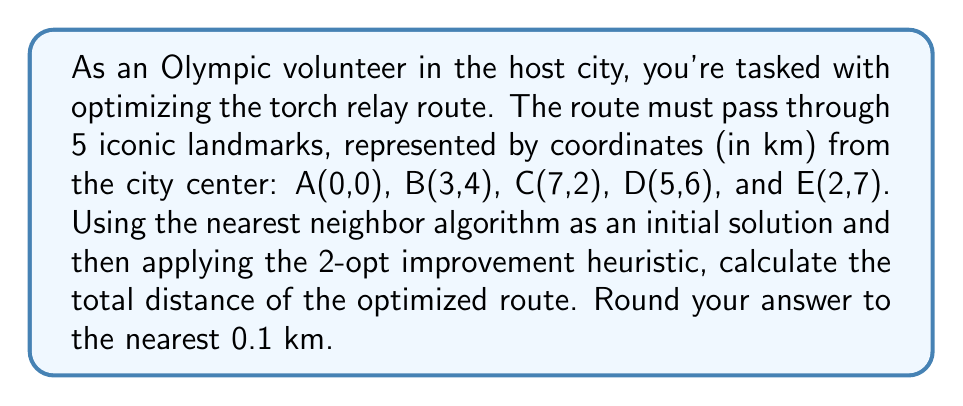Provide a solution to this math problem. 1) First, we'll use the nearest neighbor algorithm to find an initial route:
   Start at A(0,0)
   Closest to A: B(3,4), distance = $\sqrt{3^2 + 4^2} = 5$ km
   Closest to B: C(7,2), distance = $\sqrt{4^2 + (-2)^2} = \sqrt{20}$ km
   Closest to C: D(5,6), distance = $\sqrt{(-2)^2 + 4^2} = \sqrt{20}$ km
   Last point: E(2,7)
   Back to A: distance = $\sqrt{2^2 + 7^2} = \sqrt{53}$ km

   Initial route: A -> B -> C -> D -> E -> A
   Total distance: $5 + \sqrt{20} + \sqrt{20} + \sqrt{29} + \sqrt{53} \approx 23.6$ km

2) Now, apply the 2-opt improvement heuristic:
   Check all possible 2-edge swaps:
   (AB,CD) -> (AC,BD): $\sqrt{49 + 4} + \sqrt{4 + 4} = 9$ km > $5 + \sqrt{20}$, no improvement
   (AB,DE) -> (AD,BE): $\sqrt{25 + 36} + \sqrt{1 + 9} = 11 + \sqrt{10}$ km > $5 + \sqrt{29}$, no improvement
   (BC,DE) -> (BD,CE): $\sqrt{4 + 4} + \sqrt{25 + 25} = 2\sqrt{2} + \sqrt{50}$ km < $\sqrt{20} + \sqrt{29}$, improvement found

3) Update the route:
   New route: A -> B -> D -> C -> E -> A
   New total distance: $5 + 2\sqrt{2} + \sqrt{50} + \sqrt{29} + \sqrt{53} \approx 23.2$ km

4) Check for further improvements:
   No other 2-edge swaps yield a shorter distance.

5) Round to the nearest 0.1 km: 23.2 km
Answer: 23.2 km 